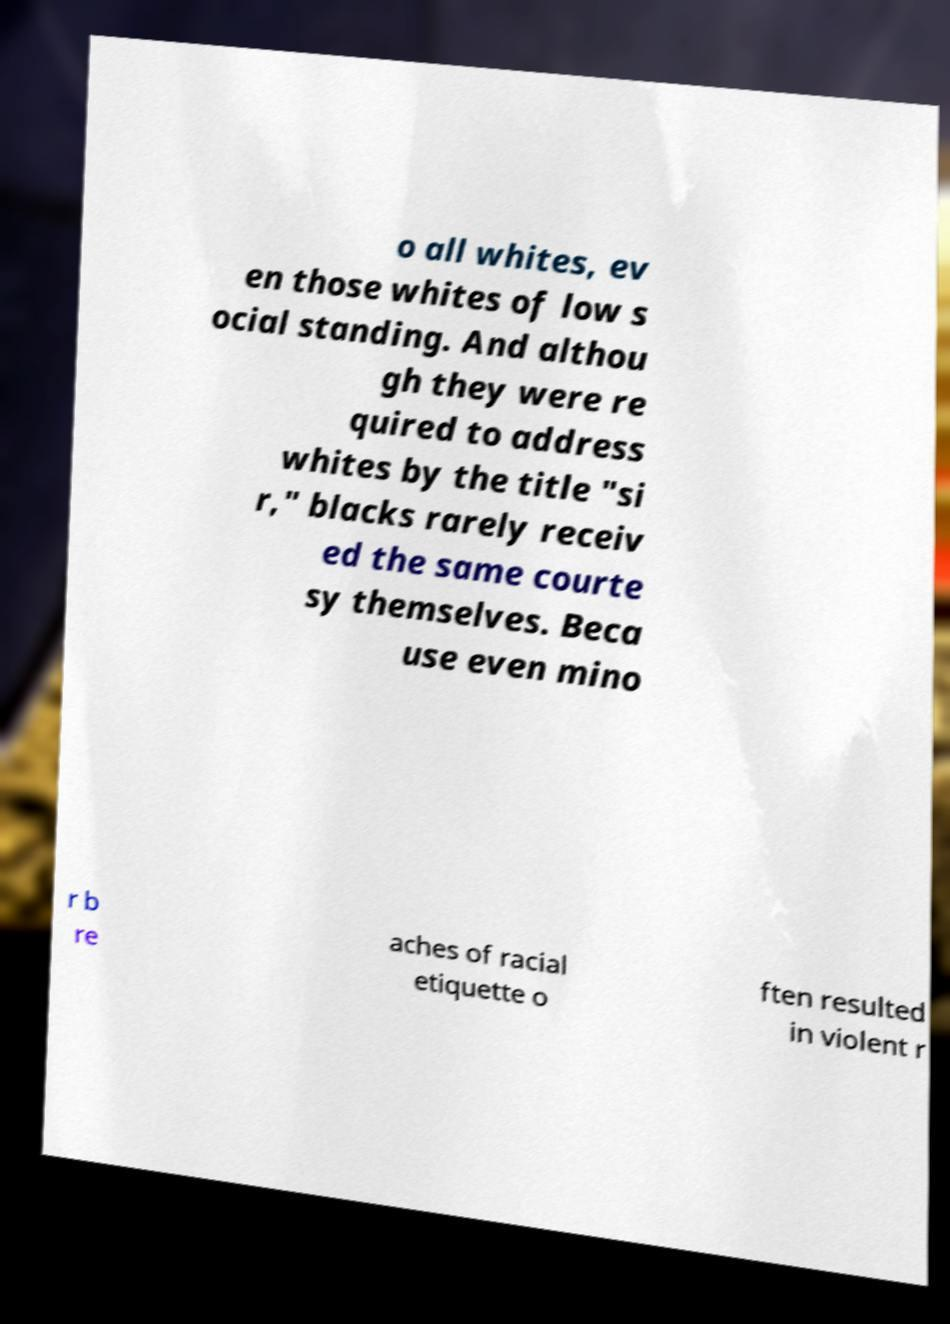For documentation purposes, I need the text within this image transcribed. Could you provide that? o all whites, ev en those whites of low s ocial standing. And althou gh they were re quired to address whites by the title "si r," blacks rarely receiv ed the same courte sy themselves. Beca use even mino r b re aches of racial etiquette o ften resulted in violent r 